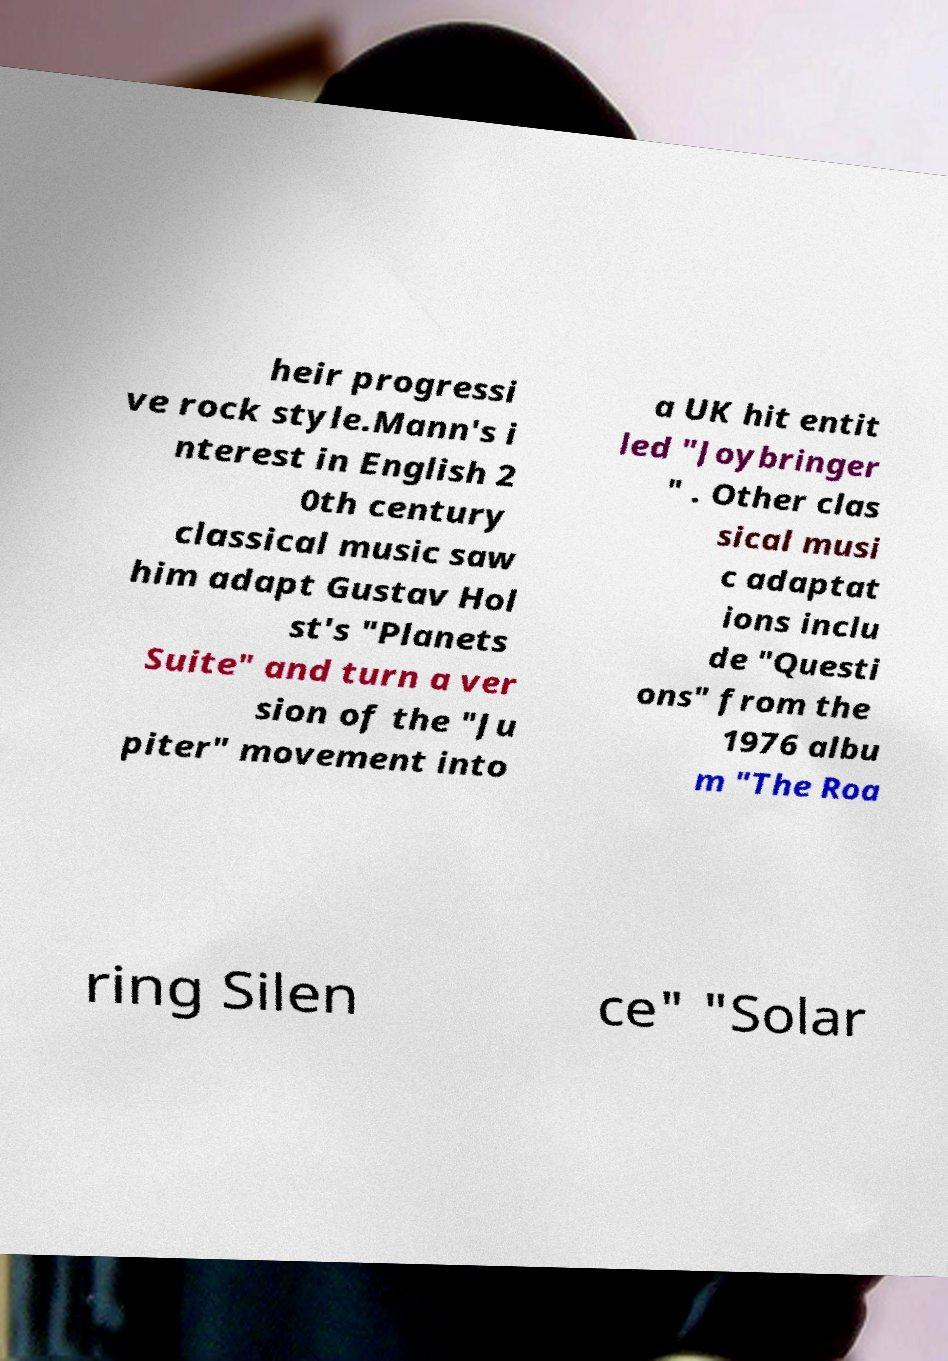Please read and relay the text visible in this image. What does it say? heir progressi ve rock style.Mann's i nterest in English 2 0th century classical music saw him adapt Gustav Hol st's "Planets Suite" and turn a ver sion of the "Ju piter" movement into a UK hit entit led "Joybringer " . Other clas sical musi c adaptat ions inclu de "Questi ons" from the 1976 albu m "The Roa ring Silen ce" "Solar 